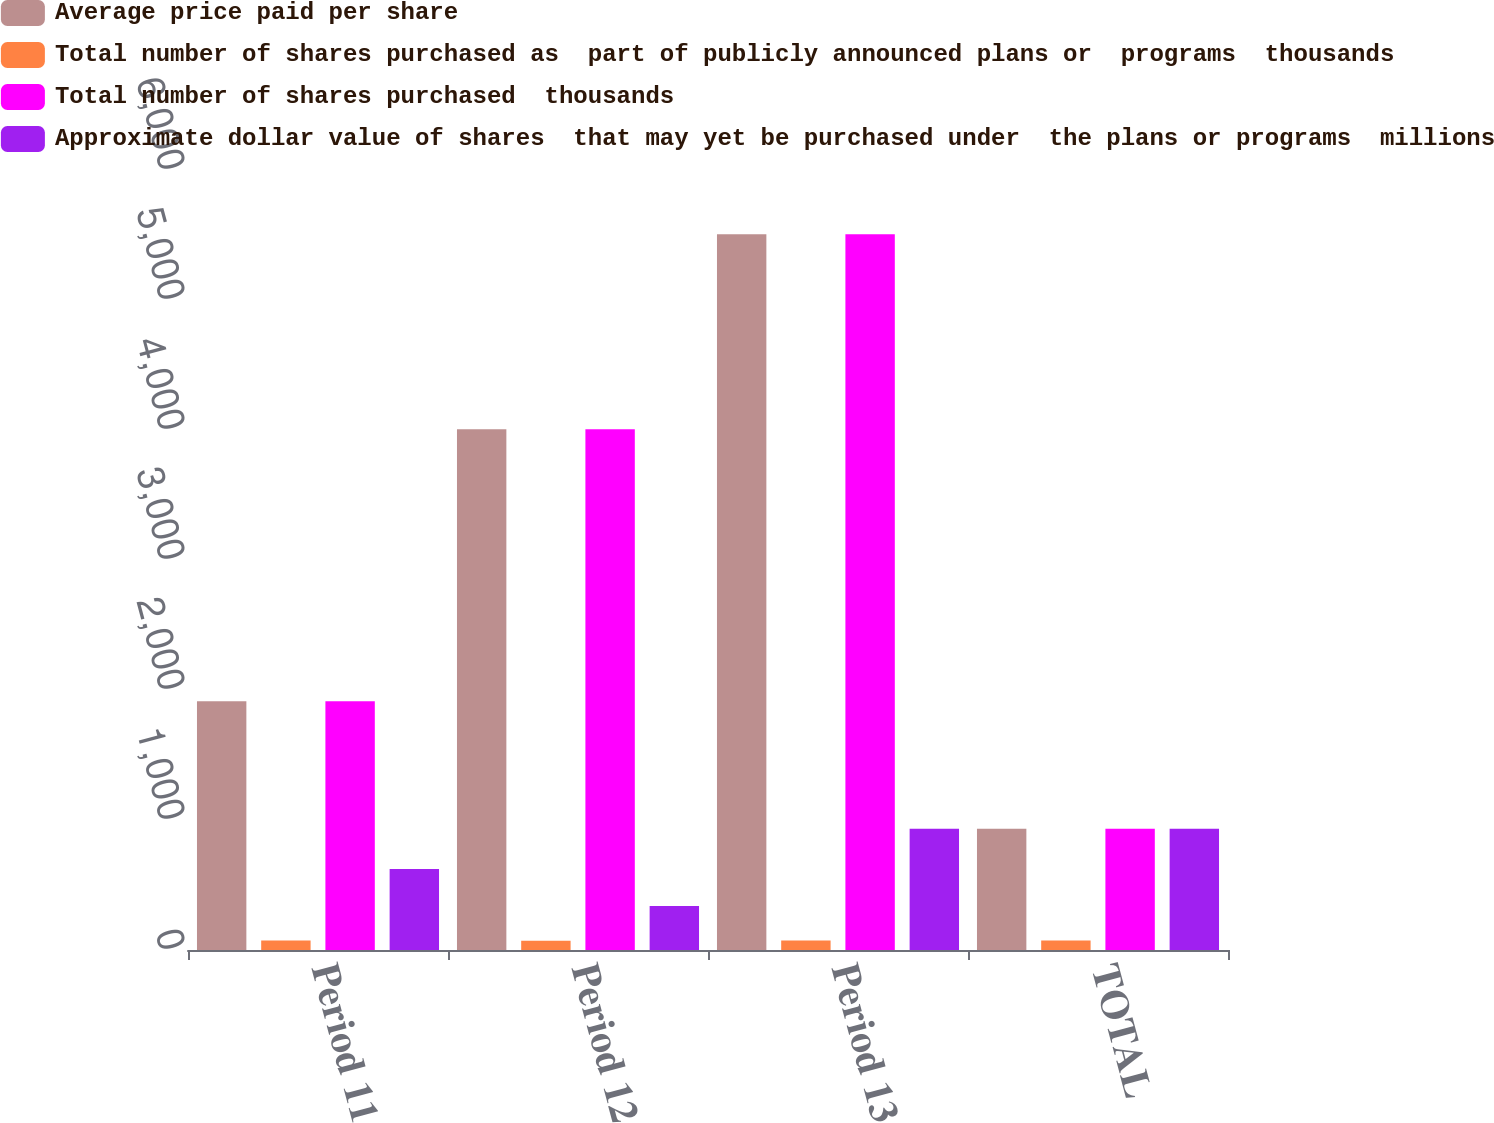Convert chart to OTSL. <chart><loc_0><loc_0><loc_500><loc_500><stacked_bar_chart><ecel><fcel>Period 11<fcel>Period 12<fcel>Period 13<fcel>TOTAL<nl><fcel>Average price paid per share<fcel>1914<fcel>4006<fcel>5506<fcel>933<nl><fcel>Total number of shares purchased as  part of publicly announced plans or  programs  thousands<fcel>73.16<fcel>71.14<fcel>73.56<fcel>72.64<nl><fcel>Total number of shares purchased  thousands<fcel>1914<fcel>4006<fcel>5506<fcel>933<nl><fcel>Approximate dollar value of shares  that may yet be purchased under  the plans or programs  millions<fcel>623<fcel>338<fcel>933<fcel>933<nl></chart> 